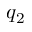Convert formula to latex. <formula><loc_0><loc_0><loc_500><loc_500>q _ { 2 }</formula> 